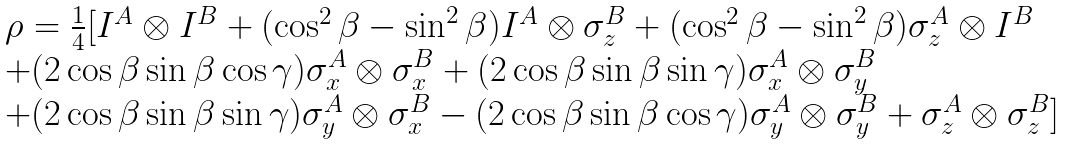<formula> <loc_0><loc_0><loc_500><loc_500>\begin{array} { l c l } \rho = \frac { 1 } { 4 } [ I ^ { A } \otimes I ^ { B } + ( \cos ^ { 2 } { \beta } - \sin ^ { 2 } { \beta } ) I ^ { A } \otimes \sigma _ { z } ^ { B } + ( \cos ^ { 2 } { \beta } - \sin ^ { 2 } { \beta } ) \sigma _ { z } ^ { A } \otimes I ^ { B } \\ + ( 2 \cos { \beta } \sin { \beta } \cos { \gamma } ) \sigma _ { x } ^ { A } \otimes \sigma _ { x } ^ { B } + ( 2 \cos { \beta } \sin { \beta } \sin { \gamma } ) \sigma _ { x } ^ { A } \otimes \sigma _ { y } ^ { B } \\ + ( 2 \cos { \beta } \sin { \beta } \sin { \gamma } ) \sigma _ { y } ^ { A } \otimes \sigma _ { x } ^ { B } - ( 2 \cos { \beta } \sin { \beta } \cos { \gamma } ) \sigma _ { y } ^ { A } \otimes \sigma _ { y } ^ { B } + \sigma _ { z } ^ { A } \otimes \sigma _ { z } ^ { B } ] \end{array}</formula> 